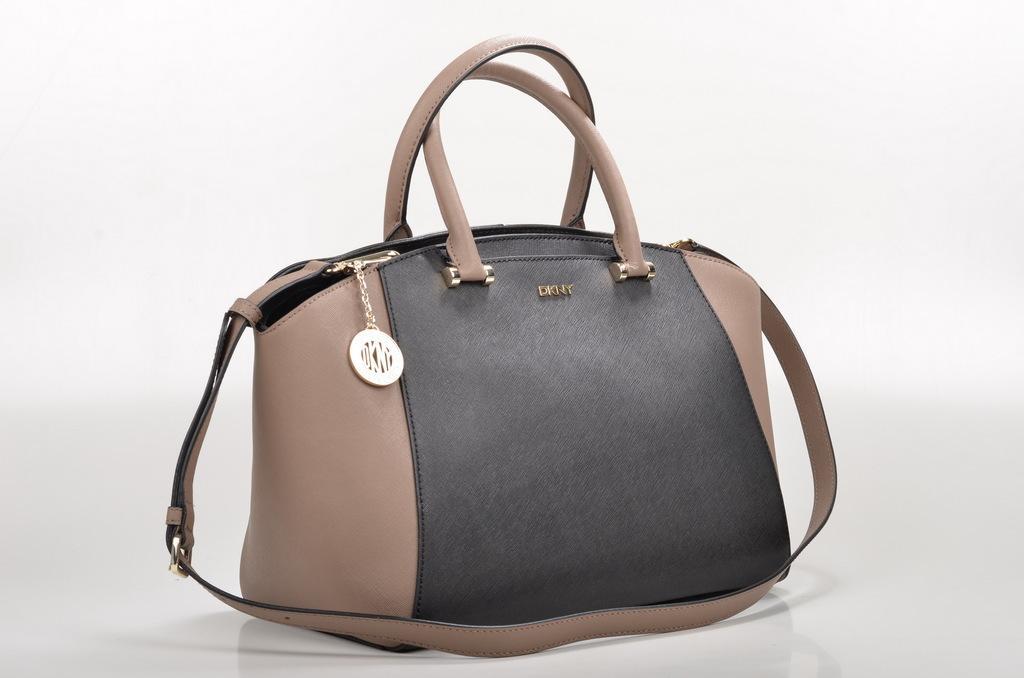Please provide a concise description of this image. In the picture we can see a handbag. Handbag is brown and black in colour, to the handbag we can see a belt, and a handle and a key chain. The key chain is gold in colour. 